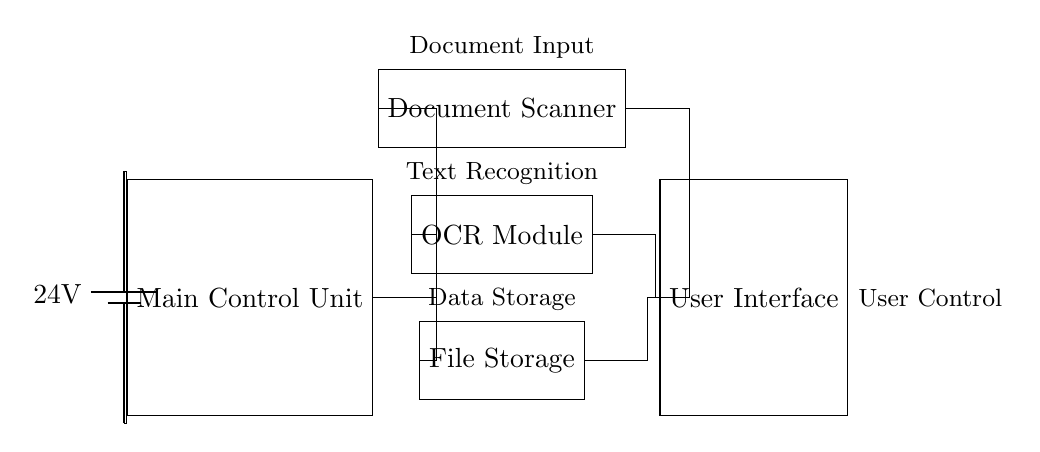What is the voltage of this circuit? The voltage is 24 volts, which is indicated by the battery symbol in the circuit diagram.
Answer: 24 volts What is the role of the MCU in this circuit? The Main Control Unit (MCU) is depicted as the central component that connects to all other parts of the circuit and controls their operation, as shown by its connections to the document scanner, OCR module, and file storage.
Answer: Control How many main components are connected to the MCU? There are three main components connected to the MCU: the document scanner, OCR module, and file storage, which can be counted from the connections drawn to the MCU.
Answer: Three What device is responsible for text recognition? The Optical Character Recognition (OCR) module is specifically labeled in the diagram as the component responsible for text recognition based on its designation and position in relation to the document scanner.
Answer: OCR Module What is the direction of data flow from the document scanner to the user interface? The data flows from the document scanner to the user interface, as depicted by the connections that go from the scanner to the UI, indicating a unidirectional flow of information.
Answer: Forward What would happen if the power supply was removed? If the power supply were removed, none of the connected components would function, as they rely on the 24 volts provided by the battery to operate, thereby severing their communication and processing capabilities.
Answer: Circuit inactive 